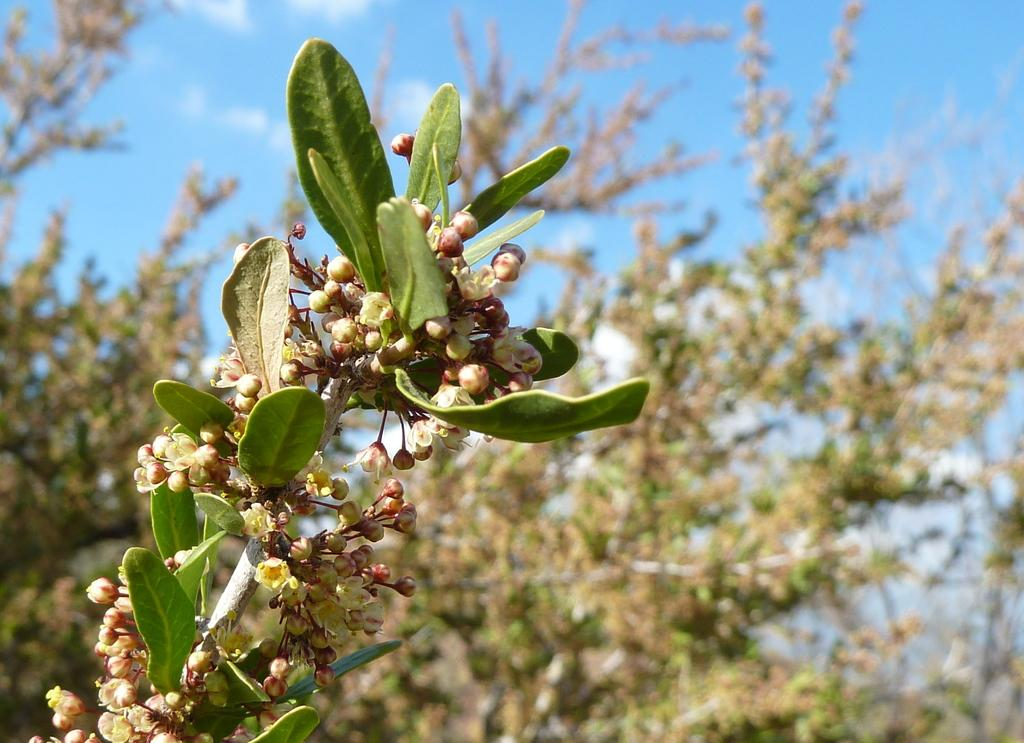What type of plant parts can be seen in the image? There are stems, leaves, flowers, and flower buds in the image. What is the condition of the background in the image? The background is blurred in the image. What can be seen in the far background of the image? There are trees and the sky visible in the background of the image. What type of game is being played in the image? There is no game present in the image; it features various plant parts and a blurred background. How does the expansion of the flower buds affect the overall composition of the image? There is no indication of the expansion of flower buds in the image, as it only shows the current state of the flowers and buds. 